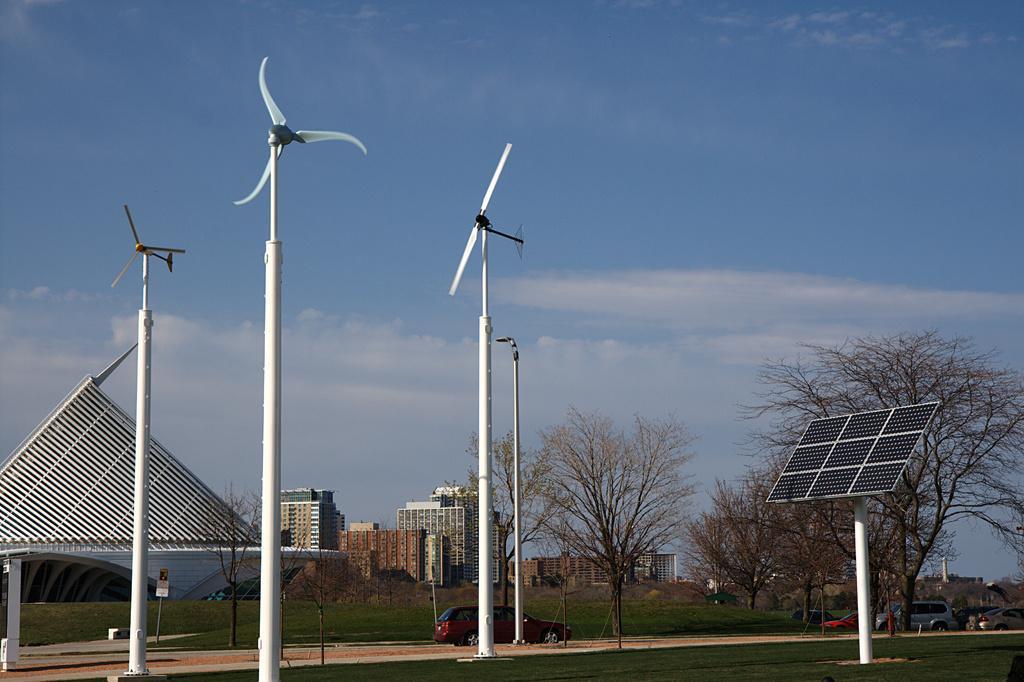In one or two sentences, can you explain what this image depicts? In this image there is a solar panel, windmills , buildings, poles, trees, vehicles, plants, grass, sky. 